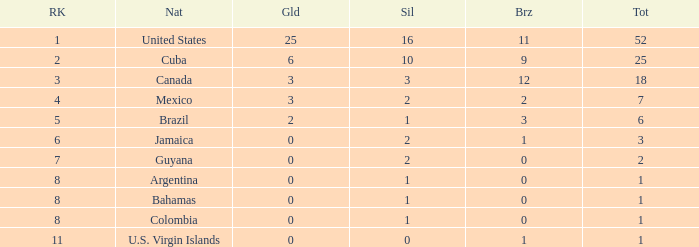What is the fewest number of silver medals a nation who ranked below 8 received? 0.0. 